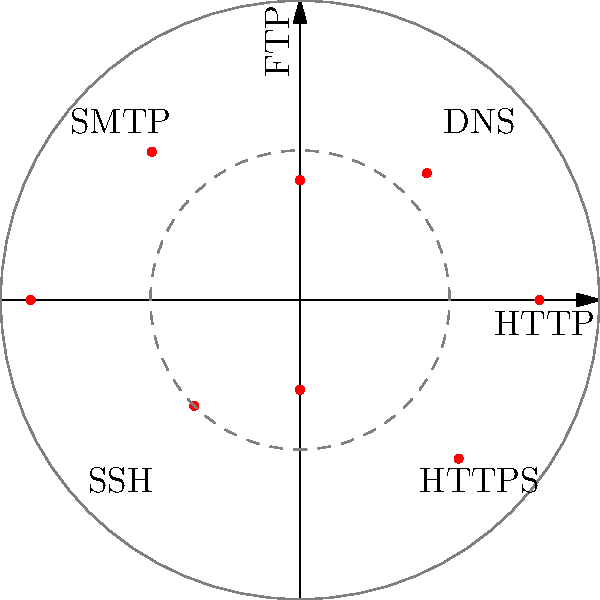In the circular radar-like display of network traffic patterns shown above, which protocol appears to have the highest traffic volume, and approximately how many units does it measure on the scale? To answer this question, we need to analyze the polar coordinate graph representing network traffic patterns:

1. The graph displays various network protocols positioned around a circular radar-like display.
2. Each protocol's traffic volume is represented by the distance of its corresponding point from the center.
3. The circular grid lines provide a scale, with the outer circle representing 100 units and the inner dashed circle representing 50 units.
4. By visually inspecting the graph, we can see that the point furthest from the center is located on the negative y-axis.
5. This point corresponds to the protocol labeled "SMTP" (Simple Mail Transfer Protocol).
6. Estimating its position relative to the grid lines, we can see that it's close to, but slightly below, the outer 100-unit circle.
7. A reasonable estimate for the SMTP traffic volume would be approximately 90 units.

Therefore, SMTP appears to have the highest traffic volume, measuring approximately 90 units on the scale.
Answer: SMTP, ~90 units 